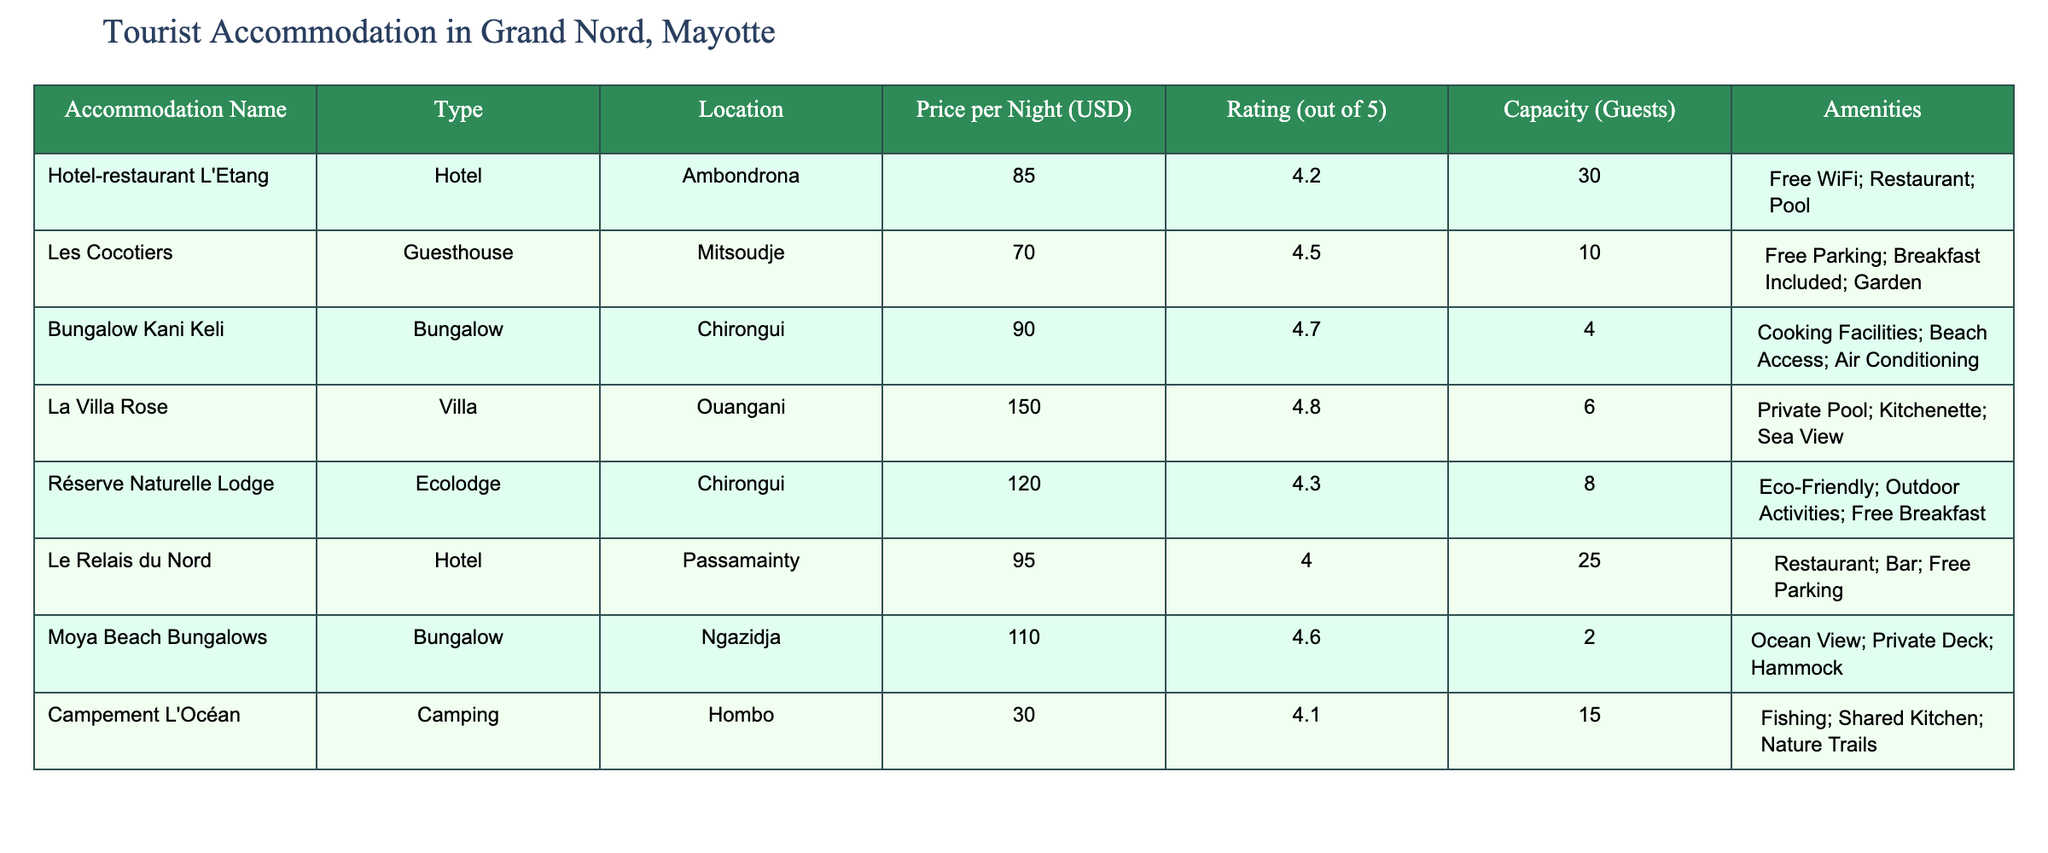What is the price per night for La Villa Rose? La Villa Rose is listed in the table under the 'Price per Night (USD)' column, which shows that it costs 150 USD per night.
Answer: 150 USD Which accommodation has the highest rating? Looking at the 'Rating (out of 5)' column, Bungalow Kani Keli has the highest rating of 4.7, followed by La Villa Rose with 4.8, though La Villa Rose has a slightly higher rating when considering only whole numbers.
Answer: La Villa Rose (4.8) How many guests can the Campement L'Océan accommodate? The 'Capacity (Guests)' column indicates that Campement L'Océan can accommodate 15 guests as listed directly in that row.
Answer: 15 guests What is the average price per night of all accommodations? To find the average, sum the prices: 85 + 70 + 90 + 150 + 120 + 95 + 110 + 30 = 900. There are 8 accommodations, so the average price is 900 / 8 = 112.5.
Answer: 112.5 USD Is there any accommodation with eco-friendly amenities? Yes, the Réserve Naturelle Lodge is labeled as an Ecolodge and includes 'Eco-Friendly' in its amenities.
Answer: Yes Which type of accommodation has the capacity for the fewest guests? The table shows that the Bungalow Kani Keli has the lowest capacity at 4 guests, indicating that bungalows generally have a smaller capacity compared to hotels and lodges.
Answer: 4 guests How many accommodations offer free WiFi? By reviewing the amenities listed, only Hotel-restaurant L'Etang and Le Relais du Nord mention free WiFi. Thus, there are two accommodations that offer this amenity.
Answer: 2 accommodations What is the total number of guests that can be accommodated across all listed accommodations? Adding up the capacities: 30 + 10 + 4 + 6 + 8 + 25 + 2 + 15 = 100. Therefore, the total capacity is 100 guests.
Answer: 100 guests Which accommodation is located in Ambondrona? Looking at the 'Location' column, Hotel-restaurant L'Etang is the accommodation listed under Ambondrona.
Answer: Hotel-restaurant L'Etang 